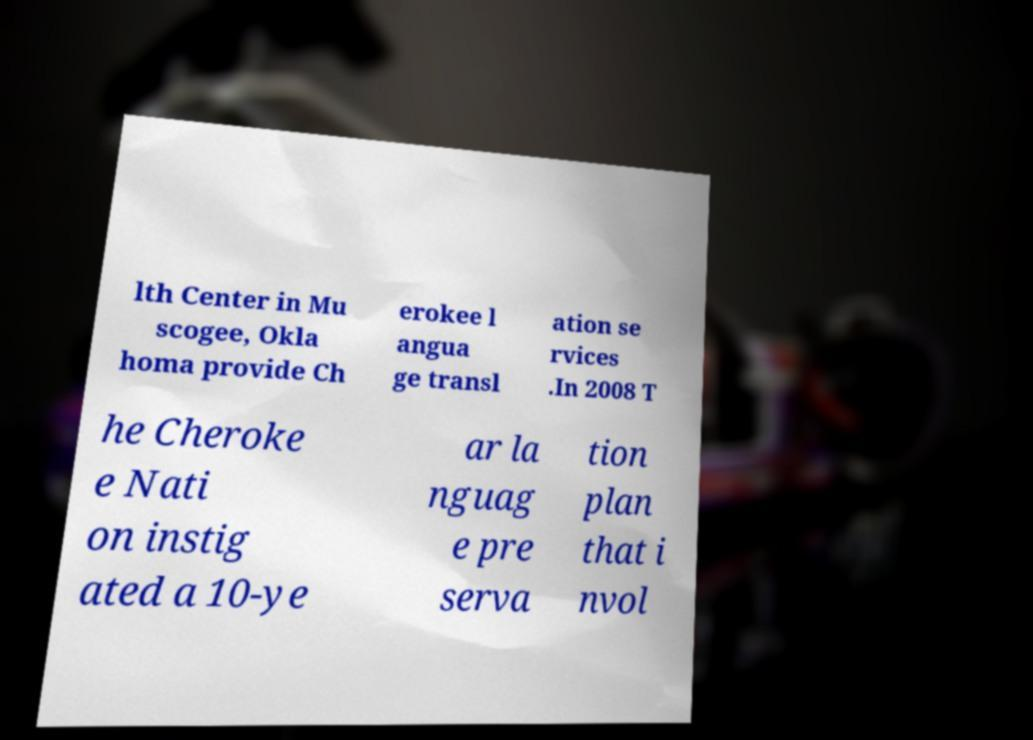Could you extract and type out the text from this image? lth Center in Mu scogee, Okla homa provide Ch erokee l angua ge transl ation se rvices .In 2008 T he Cheroke e Nati on instig ated a 10-ye ar la nguag e pre serva tion plan that i nvol 